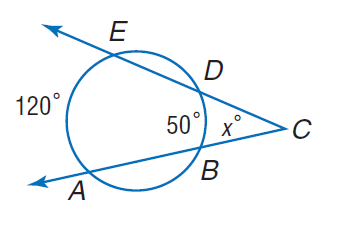Question: Find x.
Choices:
A. 35
B. 50
C. 100
D. 120
Answer with the letter. Answer: A 